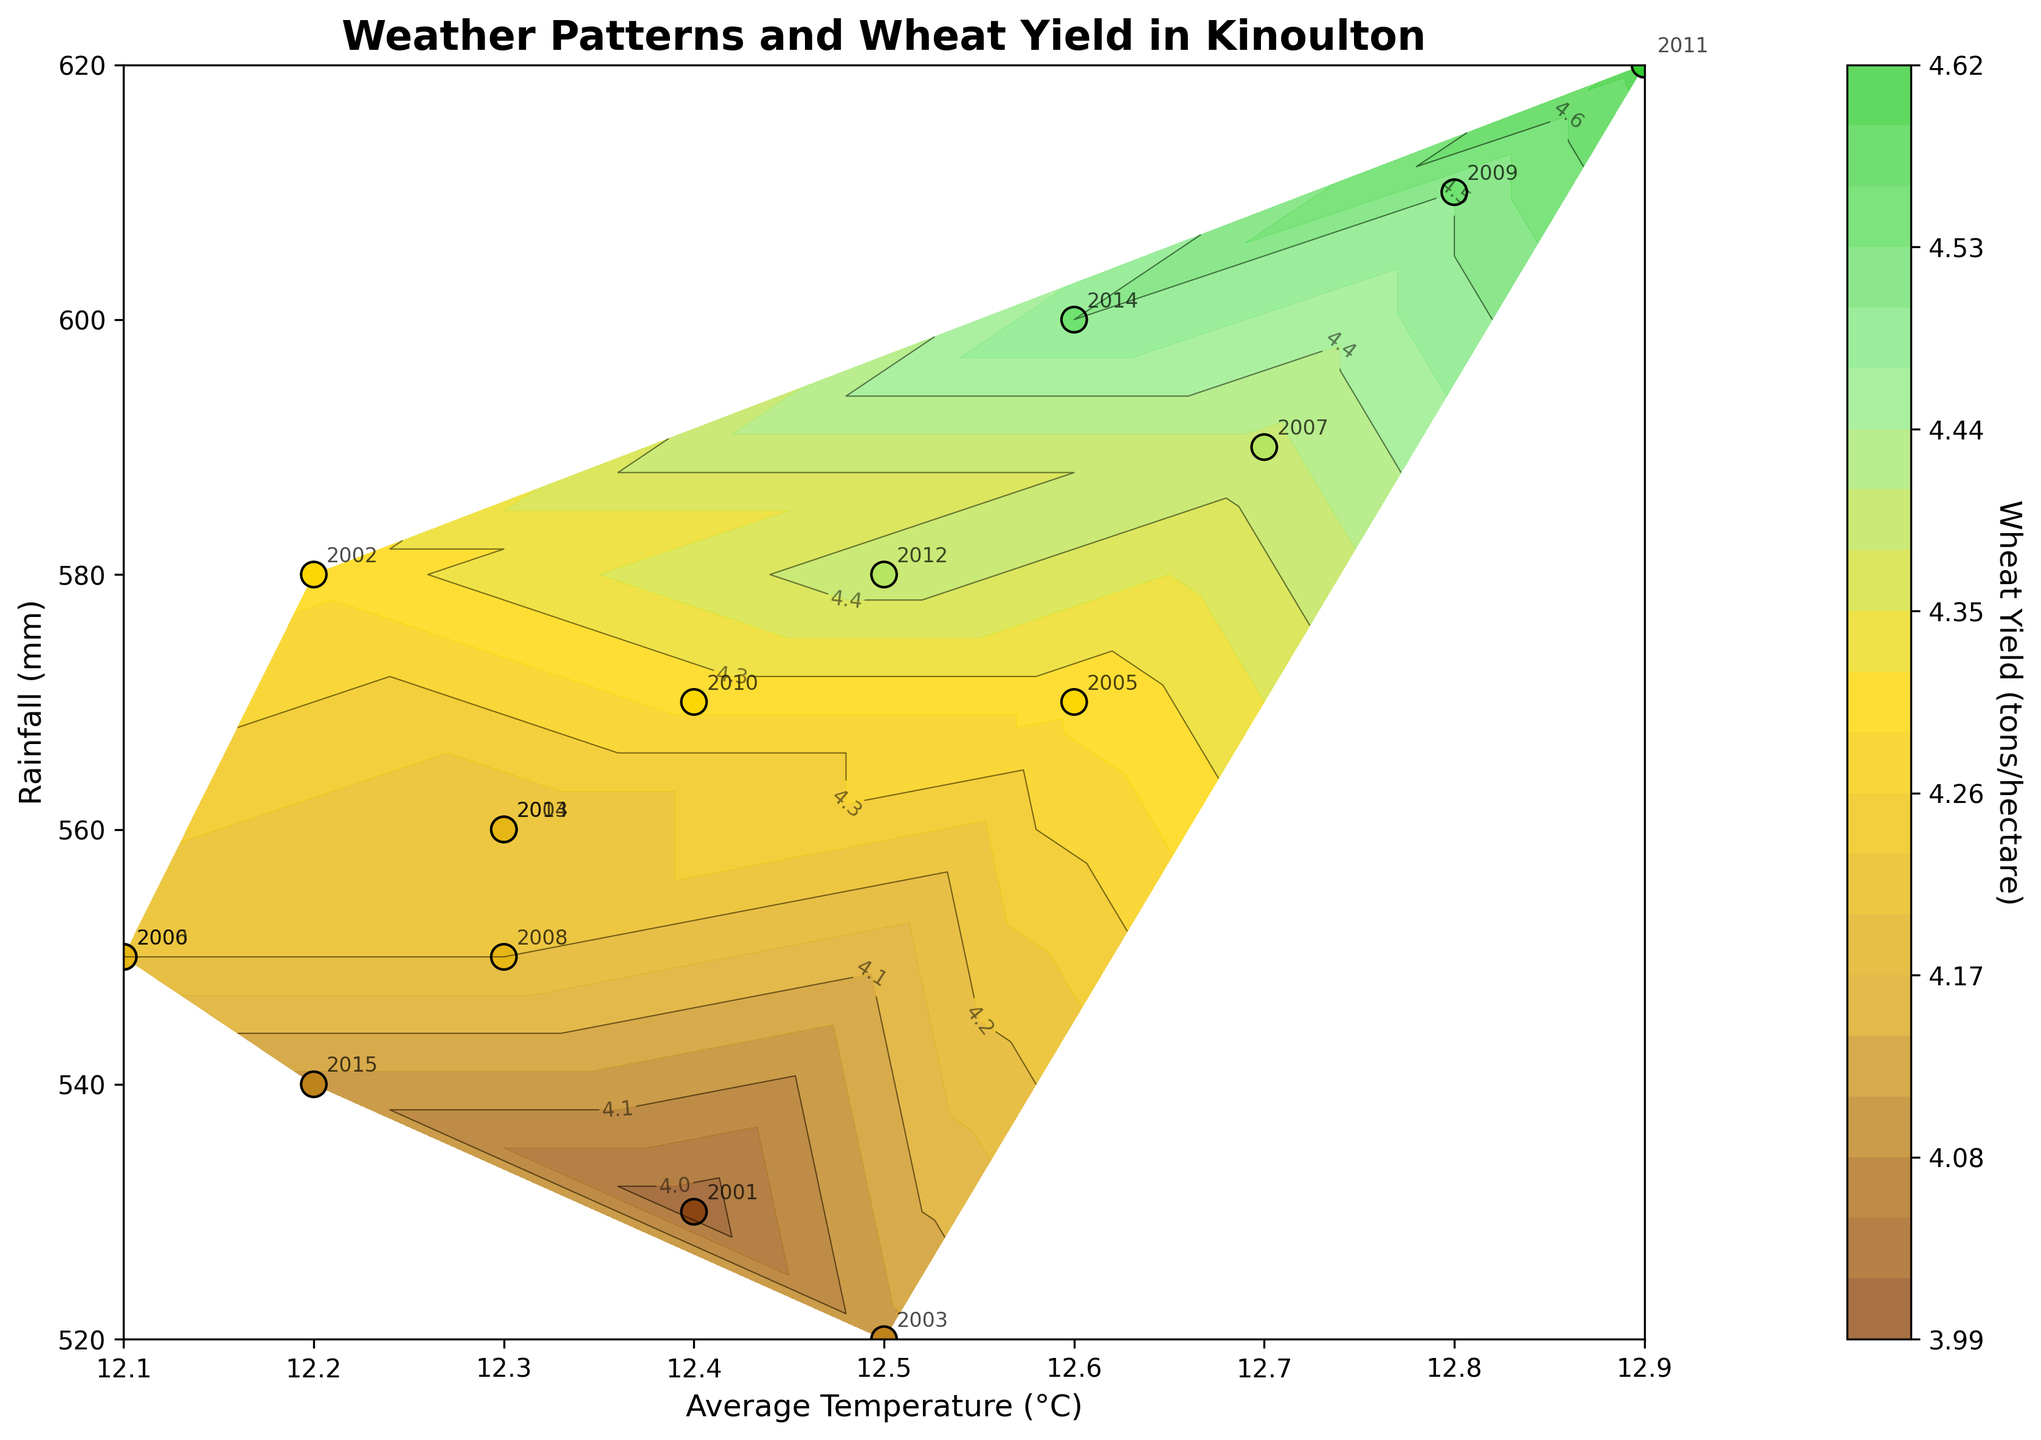What is the title of the plot? The title of the plot is displayed at the top of the figure. By reading the text, we see it is "Weather Patterns and Wheat Yield in Kinoulton".
Answer: Weather Patterns and Wheat Yield in Kinoulton Which years are annotated on the plot? By examining the plot, each data point has a year annotated next to it. By noting these annotations, we see the years from 2000 to 2015 are included.
Answer: 2000-2015 What is the range of the average temperature on the x-axis? The x-axis represents average temperature. By observing the axis ticks and labels, the temperature ranges approximately from 12.0 to 12.9°C.
Answer: 12.0 - 12.9°C Which year had the highest rainfall and what was the wheat yield for that year? By identifying the highest point on the y-axis (which represents rainfall) and finding the corresponding wheat yield value through the contour plot and year annotation, we find that 2011 had the highest rainfall of 620 mm, and the wheat yield was 4.6 tons/hectare.
Answer: 2011, 4.6 tons/hectare How does the wheat yield change with increasing average temperature? By examining the trend of the contour lines and the scatter of data points, we see that as the average temperature increases, the wheat yield also tends to increase. This is indicated by higher yield values being associated with higher temperatures.
Answer: Increases Which data point corresponds to the lowest yield of barley and what are the average temperature and rainfall for that year? Referring to the dataset and looking at the labels for barley yield (finding the lowest value of 3.6 in 2003), we then cross-reference the plot to find the temperature and rainfall associated with 2003. They are approximately 12.5°C and 520 mm, respectively.
Answer: 2003, 12.5°C, 520 mm In which year did both the average temperature and wheat yield reach their highest values? Observing the highest values of average temperature (12.9°C) and matching it to the highest contour level, we find that the year 2011 had both the highest average temperature and wheat yield (4.6 tons/hectare).
Answer: 2011 What is the relationship between the average temperature and rainfall? By examining the scatter of data points on the figure, there isn't a clear pattern that directly correlates average temperature and rainfall. The points are fairly dispersed. This suggests no strong direct relationship is apparent from the visual data.
Answer: No strong direct relationship Which year has the most prominent increase in wheat yield compared to its previous year? By inspecting the contour plot and year annotations, we identify that from 2010 to 2011, there’s a noticeable increase in wheat yield from 4.3 to 4.6 tons/hectare, making it the most prominent increase.
Answer: 2011 